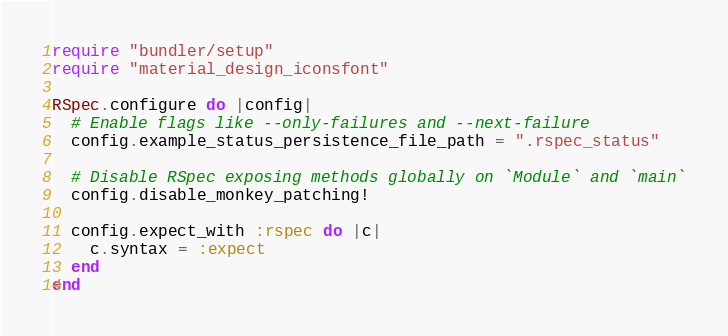Convert code to text. <code><loc_0><loc_0><loc_500><loc_500><_Ruby_>require "bundler/setup"
require "material_design_iconsfont"

RSpec.configure do |config|
  # Enable flags like --only-failures and --next-failure
  config.example_status_persistence_file_path = ".rspec_status"

  # Disable RSpec exposing methods globally on `Module` and `main`
  config.disable_monkey_patching!

  config.expect_with :rspec do |c|
    c.syntax = :expect
  end
end
</code> 